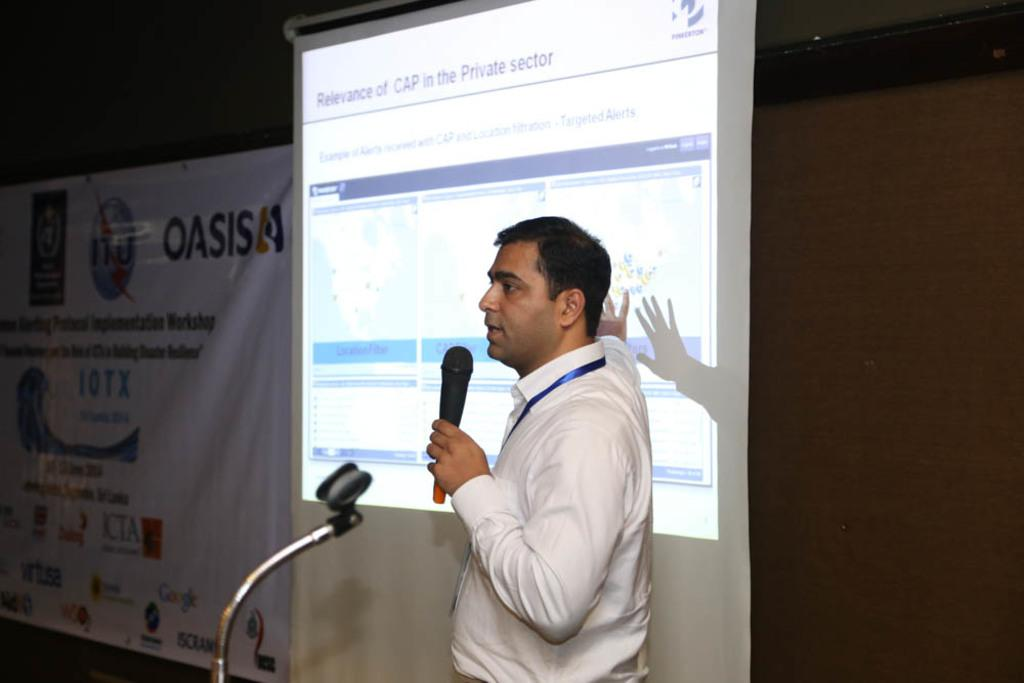What is the man in the image doing? The man is standing in the image and holding a microphone. What might the man be using the microphone for? The man might be using the microphone for speaking or presenting. What can be seen in the background of the image? There is a screen and a banner in the background of the image. What type of yarn is being used to create the banner in the image? There is no yarn present in the image, as the banner is not made of yarn. 